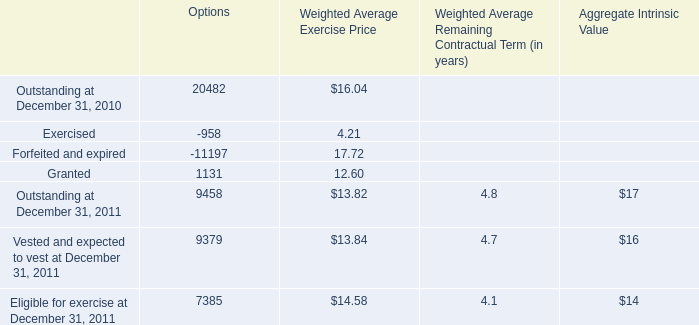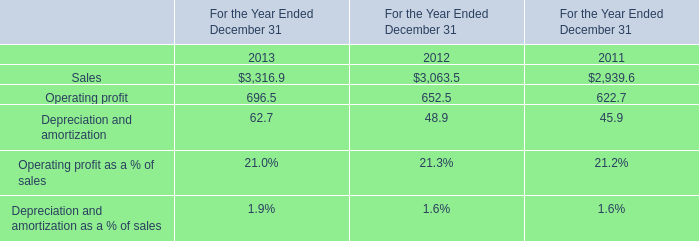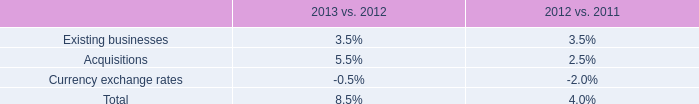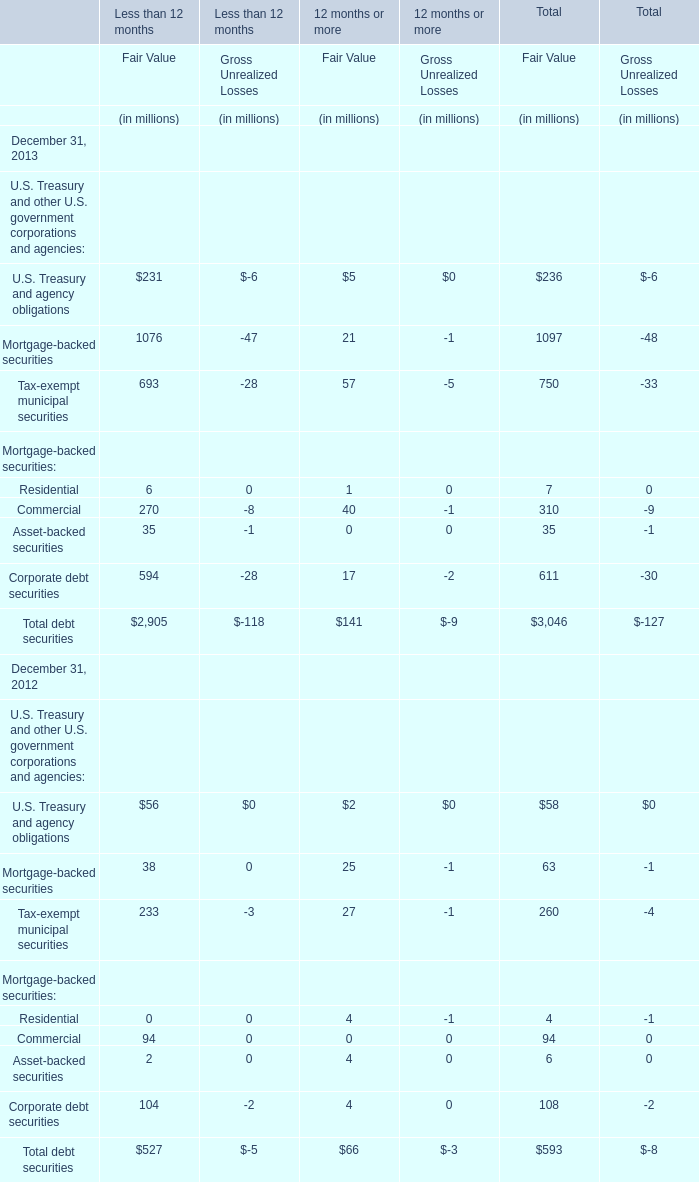What's the increasing rate of Commercial for Fair Value of Total in 2013? 
Computations: ((310 - 94) / 94)
Answer: 2.29787. 